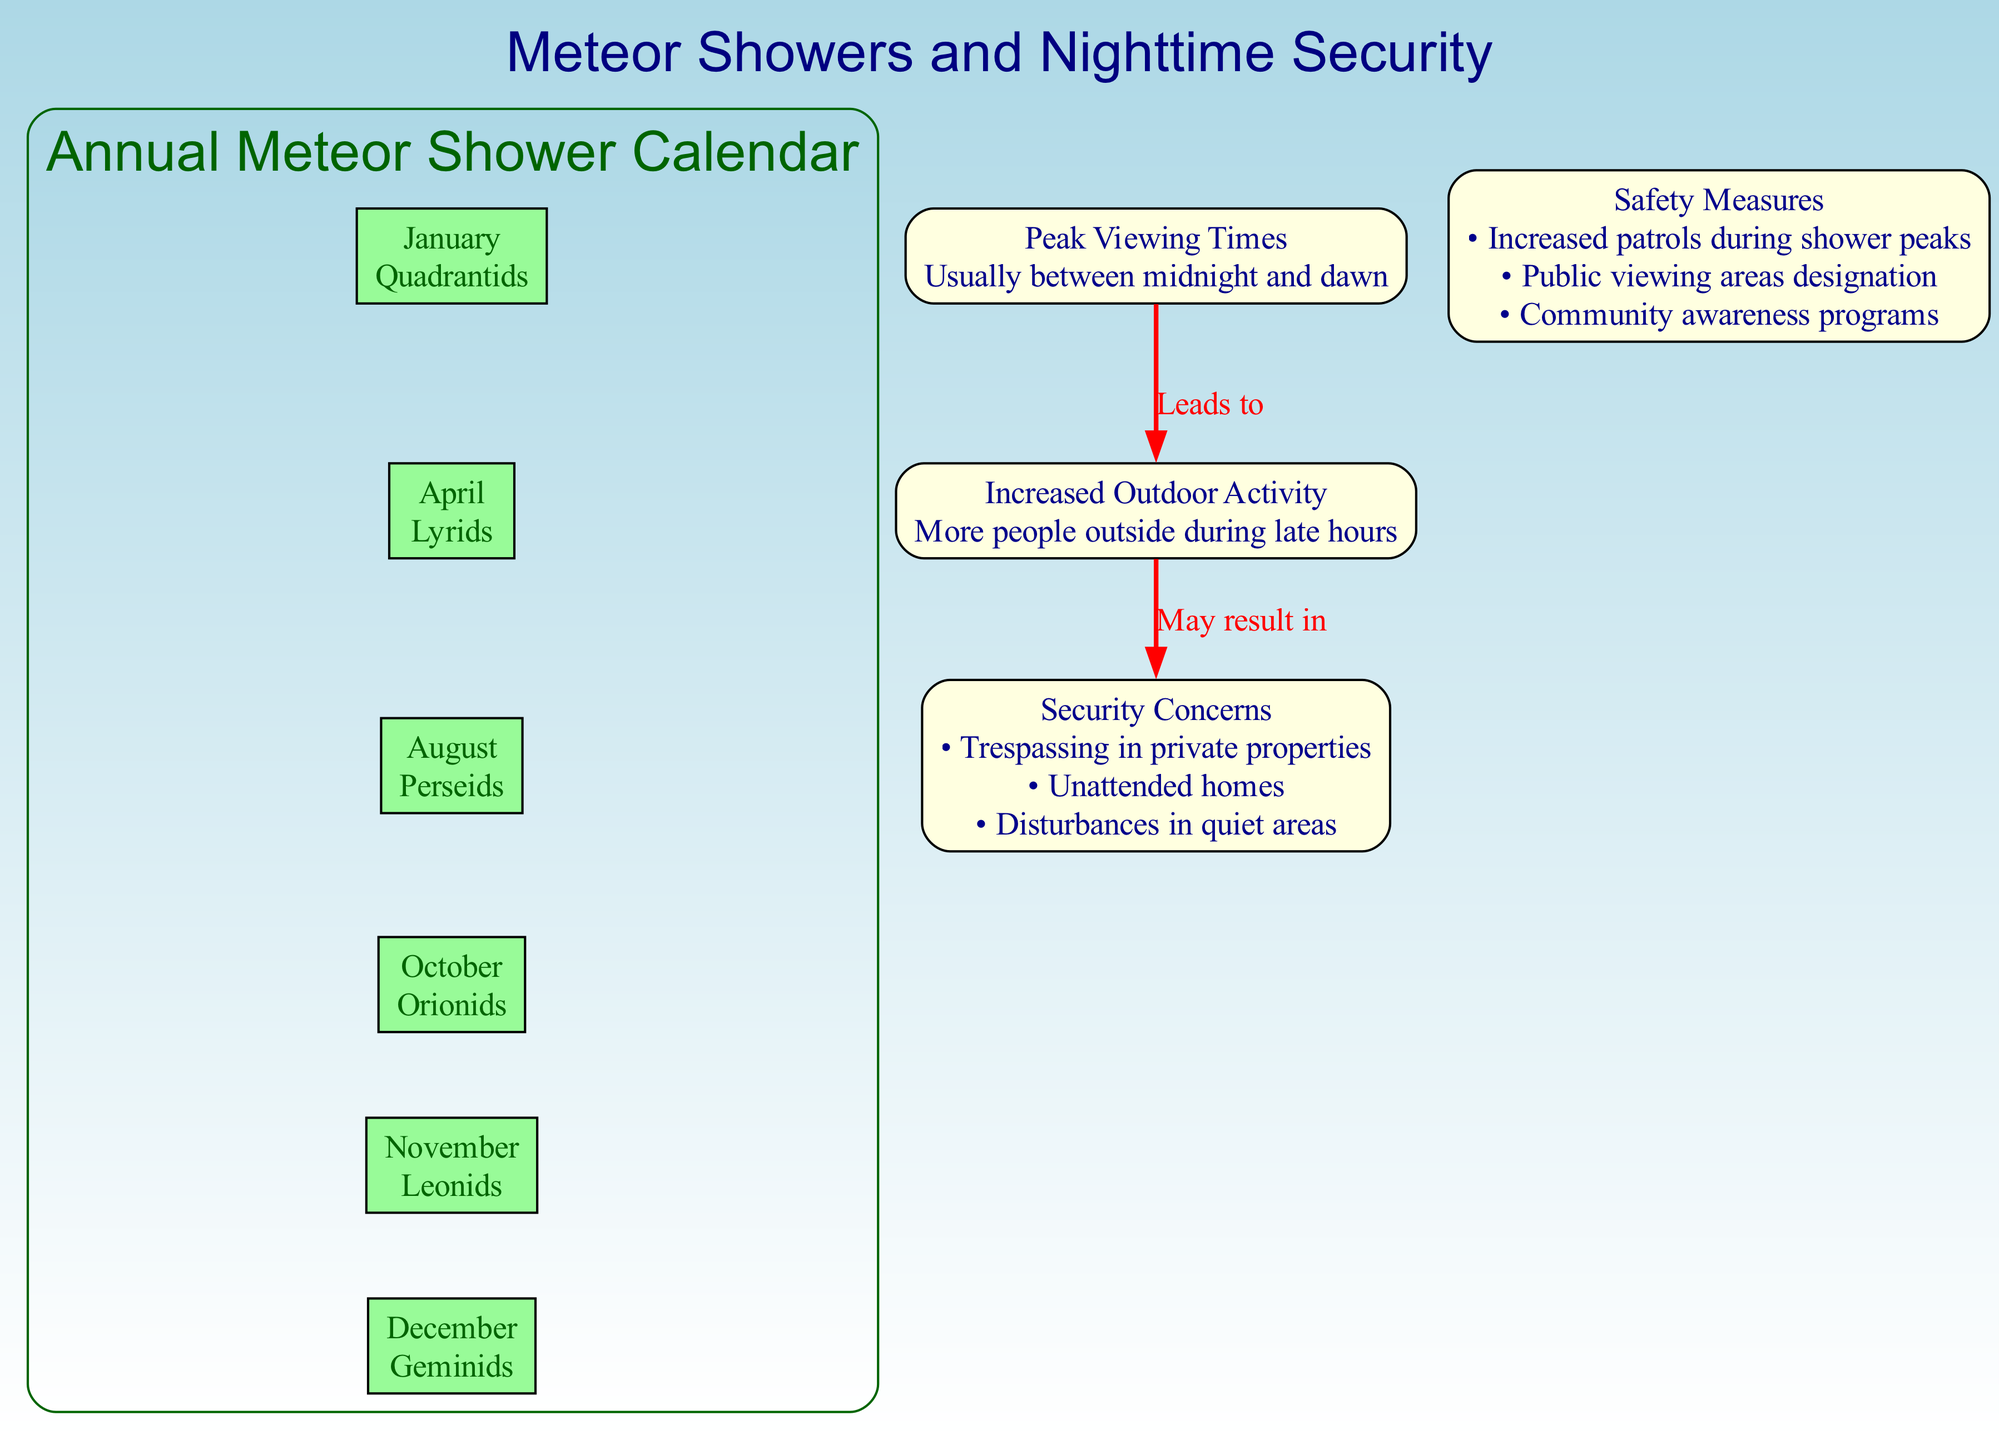What meteor shower occurs in January? The diagram lists the meteor showers associated with each month, indicating that the Quadrantids happens in January.
Answer: Quadrantids What are the peak viewing times for meteor showers? The diagram specifies that peak viewing times usually occur between midnight and dawn, making this the timeframe for the greatest visibility of meteor showers.
Answer: Between midnight and dawn How many major meteor showers are listed in the diagram? By counting the meteor showers mentioned for each month, there are a total of six major meteor showers in the diagram.
Answer: 6 What security concern is associated with increased outdoor activity? The diagram clearly shows a connection from increased outdoor activity to security concerns, specifically indicating that it may result in trespassing in private properties.
Answer: Trespassing in private properties What safety measure is recommended during shower peaks? The diagram indicates that one of the safety measures to be employed during peak meteor shower times is to increase patrols.
Answer: Increased patrols during shower peaks What month features the Perseids meteor shower? In the annual meteor shower calendar, the diagram identifies that the Perseids meteor shower is noted for August.
Answer: August What might increased nighttime outdoor activities lead to? The diagram explicitly states that increased outdoor activity may lead to security concerns, highlighting the risk of disturbances in quiet areas as one of them.
Answer: Security concerns What does the "Increased Outdoor Activity" node connect to? The diagram shows a direct connection from the "Increased Outdoor Activity" node to the "Security Concerns" node with the label "May result in," denoting that these two concepts are related.
Answer: Security Concerns What is the main theme of this diagram? The overall theme of the diagram is about the relationship between meteor showers, increased nighttime activity during their peaks, and associated security concerns, effectively creating an informative structure to understand these phenomena.
Answer: Meteor Showers and Nighttime Security 